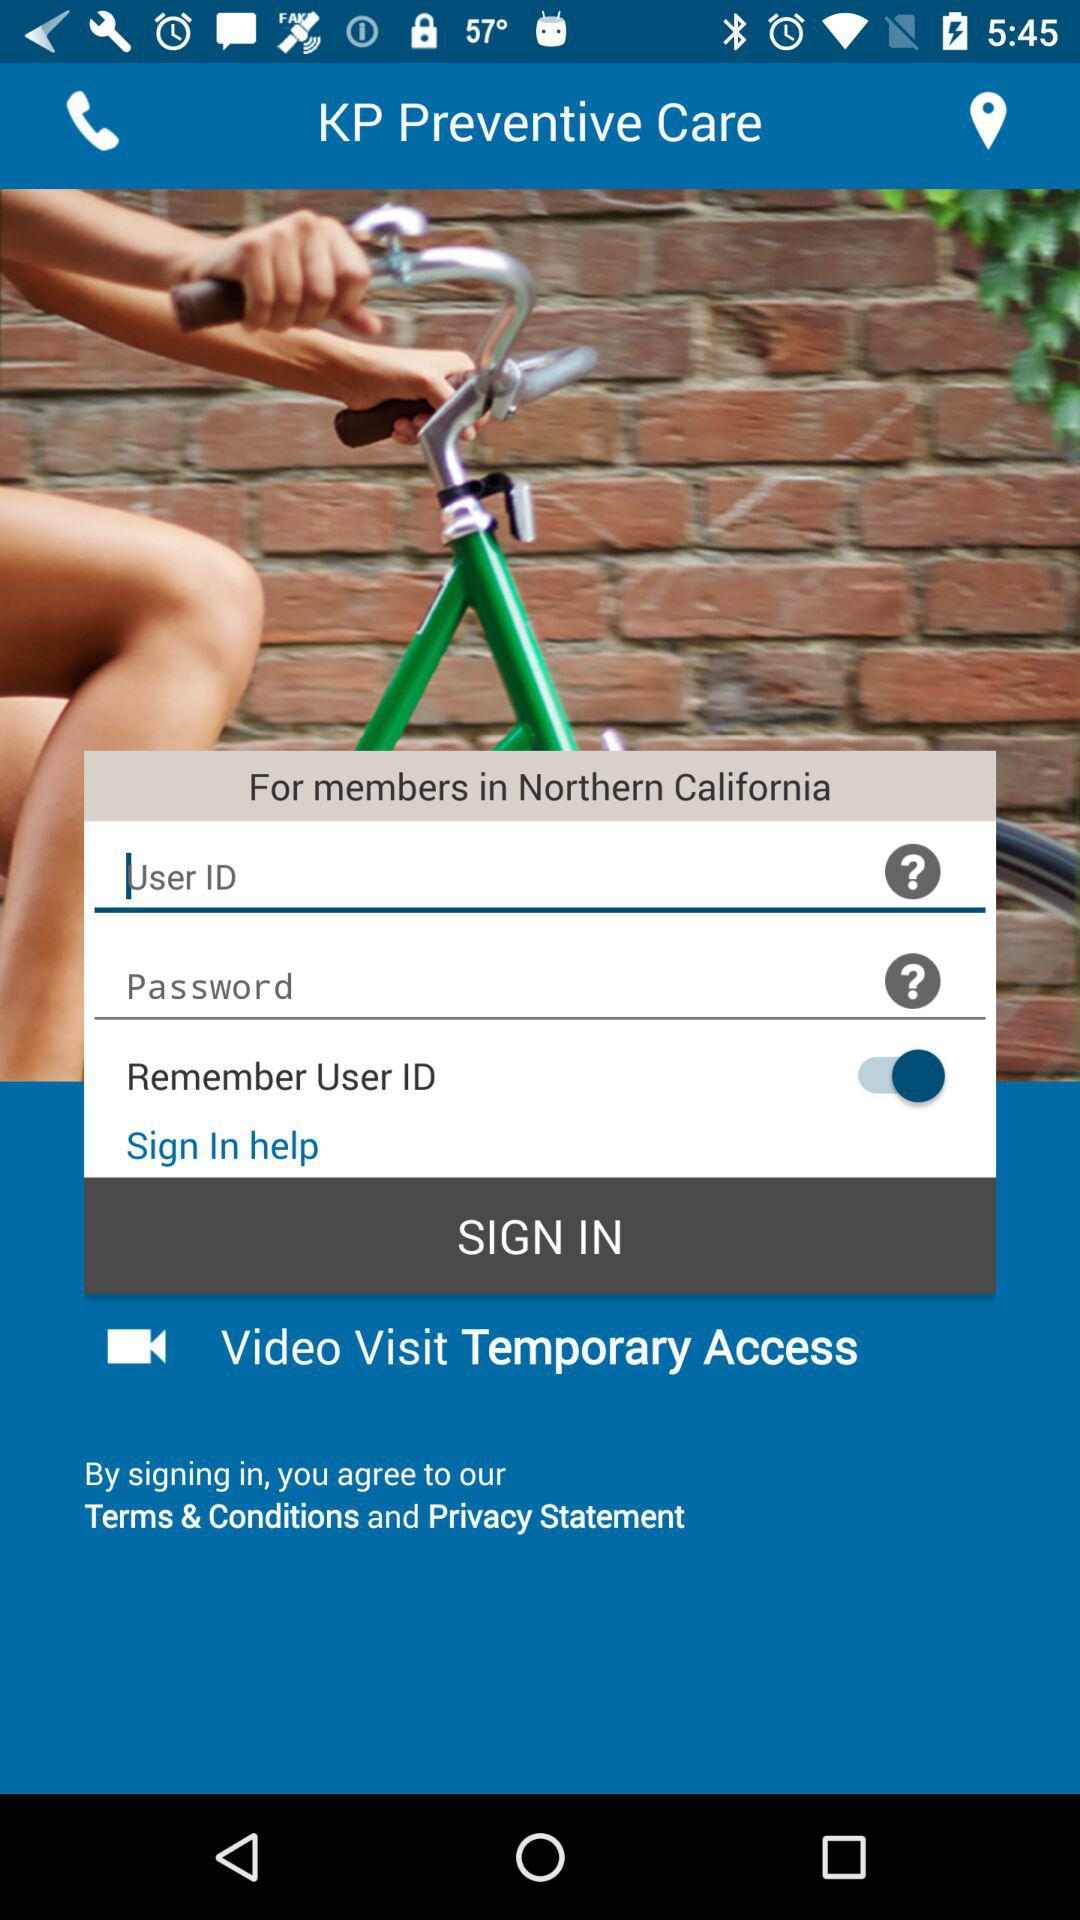What type of access is given for "Video Visit"? The type of access given is "Temporary Access". 